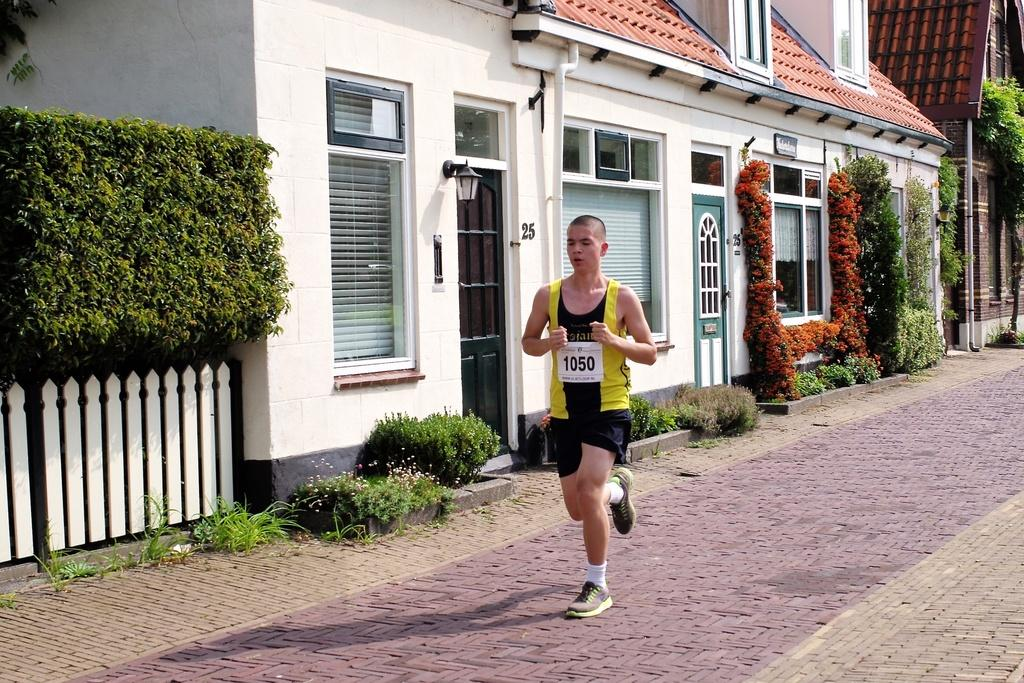What is the person in the image doing? The person in the image is jogging. What can be seen in the background of the image? There are plants and houses visible in the background of the image. What type of table is the person using to drink juice in the image? There is no table or juice present in the image; the person is jogging. What type of soda is the person holding in the image? There is no soda present in the image; the person is jogging. 